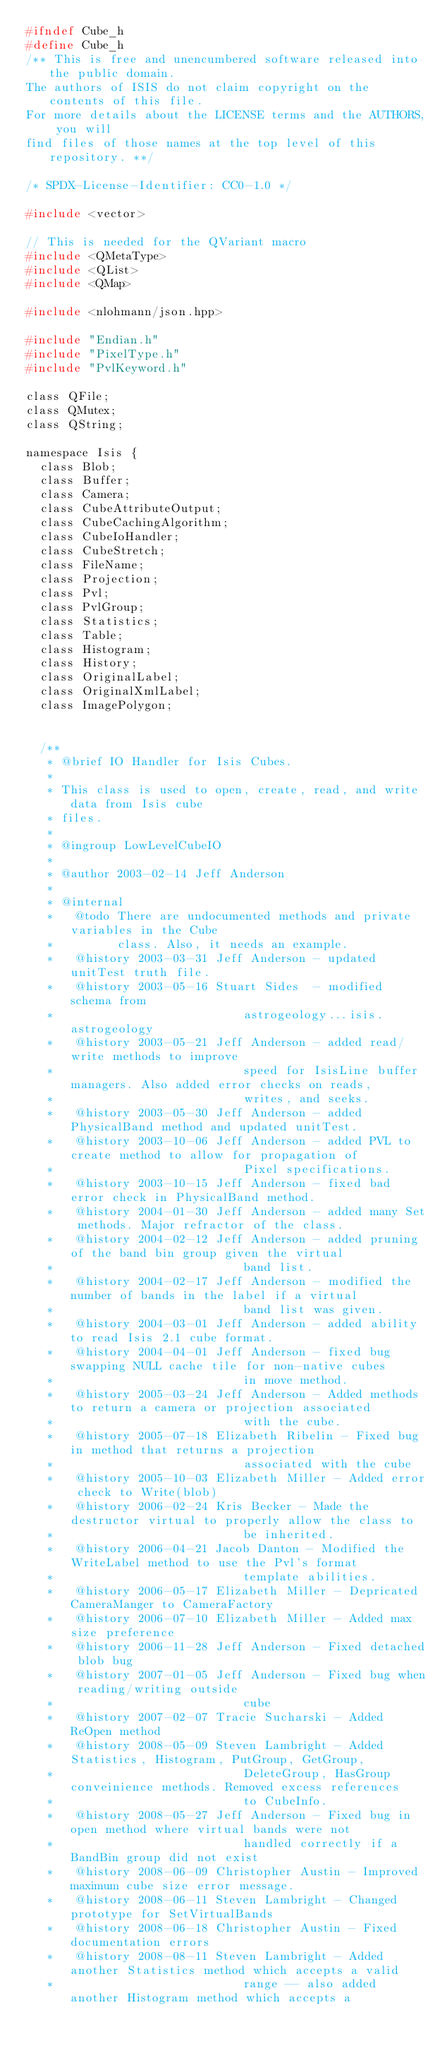<code> <loc_0><loc_0><loc_500><loc_500><_C_>#ifndef Cube_h
#define Cube_h
/** This is free and unencumbered software released into the public domain.
The authors of ISIS do not claim copyright on the contents of this file.
For more details about the LICENSE terms and the AUTHORS, you will
find files of those names at the top level of this repository. **/

/* SPDX-License-Identifier: CC0-1.0 */

#include <vector>

// This is needed for the QVariant macro
#include <QMetaType>
#include <QList>
#include <QMap>

#include <nlohmann/json.hpp>

#include "Endian.h"
#include "PixelType.h"
#include "PvlKeyword.h"

class QFile;
class QMutex;
class QString;

namespace Isis {
  class Blob;
  class Buffer;
  class Camera;
  class CubeAttributeOutput;
  class CubeCachingAlgorithm;
  class CubeIoHandler;
  class CubeStretch;
  class FileName;
  class Projection;
  class Pvl;
  class PvlGroup;
  class Statistics;
  class Table;
  class Histogram;
  class History;
  class OriginalLabel;
  class OriginalXmlLabel;
  class ImagePolygon;


  /**
   * @brief IO Handler for Isis Cubes.
   *
   * This class is used to open, create, read, and write data from Isis cube
   * files.
   *
   * @ingroup LowLevelCubeIO
   *
   * @author 2003-02-14 Jeff Anderson
   *
   * @internal
   *   @todo There are undocumented methods and private variables in the Cube
   *         class. Also, it needs an example.
   *   @history 2003-03-31 Jeff Anderson - updated unitTest truth file.
   *   @history 2003-05-16 Stuart Sides  - modified schema from
   *                           astrogeology...isis.astrogeology
   *   @history 2003-05-21 Jeff Anderson - added read/write methods to improve
   *                           speed for IsisLine buffer managers. Also added error checks on reads,
   *                           writes, and seeks.
   *   @history 2003-05-30 Jeff Anderson - added PhysicalBand method and updated unitTest.
   *   @history 2003-10-06 Jeff Anderson - added PVL to create method to allow for propagation of
   *                           Pixel specifications.
   *   @history 2003-10-15 Jeff Anderson - fixed bad error check in PhysicalBand method.
   *   @history 2004-01-30 Jeff Anderson - added many Set methods. Major refractor of the class.
   *   @history 2004-02-12 Jeff Anderson - added pruning of the band bin group given the virtual
   *                           band list.
   *   @history 2004-02-17 Jeff Anderson - modified the number of bands in the label if a virtual
   *                           band list was given.
   *   @history 2004-03-01 Jeff Anderson - added ability to read Isis 2.1 cube format.
   *   @history 2004-04-01 Jeff Anderson - fixed bug swapping NULL cache tile for non-native cubes
   *                           in move method.
   *   @history 2005-03-24 Jeff Anderson - Added methods to return a camera or projection associated
   *                           with the cube.
   *   @history 2005-07-18 Elizabeth Ribelin - Fixed bug in method that returns a projection
   *                           associated with the cube
   *   @history 2005-10-03 Elizabeth Miller - Added error check to Write(blob)
   *   @history 2006-02-24 Kris Becker - Made the destructor virtual to properly allow the class to
   *                           be inherited.
   *   @history 2006-04-21 Jacob Danton - Modified the WriteLabel method to use the Pvl's format
   *                           template abilities.
   *   @history 2006-05-17 Elizabeth Miller - Depricated CameraManger to CameraFactory
   *   @history 2006-07-10 Elizabeth Miller - Added max size preference
   *   @history 2006-11-28 Jeff Anderson - Fixed detached blob bug
   *   @history 2007-01-05 Jeff Anderson - Fixed bug when reading/writing outside
   *                           cube
   *   @history 2007-02-07 Tracie Sucharski - Added ReOpen method
   *   @history 2008-05-09 Steven Lambright - Added Statistics, Histogram, PutGroup, GetGroup,
   *                           DeleteGroup, HasGroup conveinience methods. Removed excess references
   *                           to CubeInfo.
   *   @history 2008-05-27 Jeff Anderson - Fixed bug in open method where virtual bands were not
   *                           handled correctly if a BandBin group did not exist
   *   @history 2008-06-09 Christopher Austin - Improved maximum cube size error message.
   *   @history 2008-06-11 Steven Lambright - Changed prototype for SetVirtualBands
   *   @history 2008-06-18 Christopher Austin - Fixed documentation errors
   *   @history 2008-08-11 Steven Lambright - Added another Statistics method which accepts a valid
   *                           range -- also added another Histogram method which accepts a</code> 